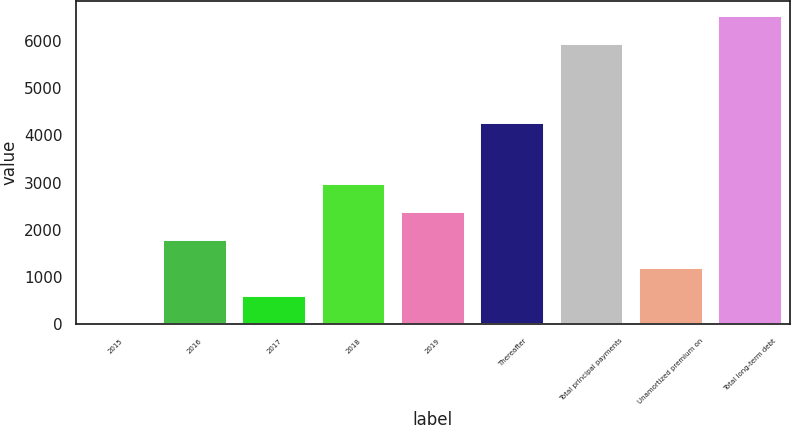Convert chart to OTSL. <chart><loc_0><loc_0><loc_500><loc_500><bar_chart><fcel>2015<fcel>2016<fcel>2017<fcel>2018<fcel>2019<fcel>Thereafter<fcel>Total principal payments<fcel>Unamortized premium on<fcel>Total long-term debt<nl><fcel>3<fcel>1780.5<fcel>595.5<fcel>2965.5<fcel>2373<fcel>4252<fcel>5925<fcel>1188<fcel>6517.5<nl></chart> 